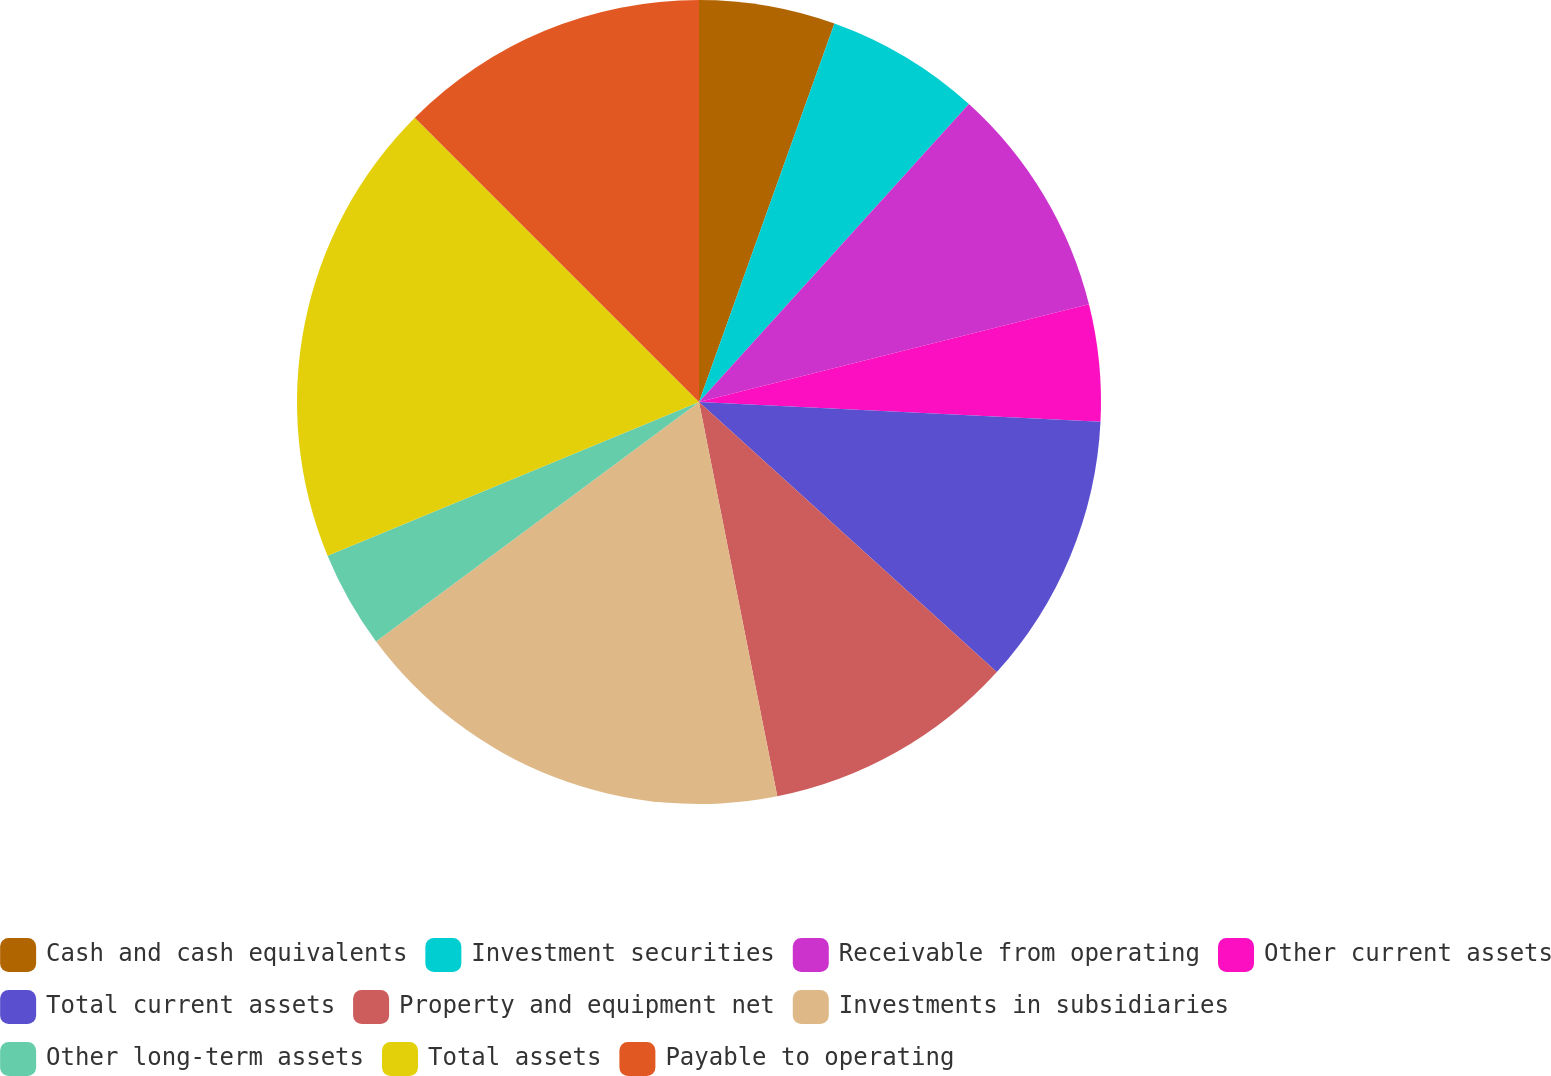Convert chart to OTSL. <chart><loc_0><loc_0><loc_500><loc_500><pie_chart><fcel>Cash and cash equivalents<fcel>Investment securities<fcel>Receivable from operating<fcel>Other current assets<fcel>Total current assets<fcel>Property and equipment net<fcel>Investments in subsidiaries<fcel>Other long-term assets<fcel>Total assets<fcel>Payable to operating<nl><fcel>5.47%<fcel>6.25%<fcel>9.38%<fcel>4.69%<fcel>10.94%<fcel>10.16%<fcel>17.97%<fcel>3.91%<fcel>18.75%<fcel>12.5%<nl></chart> 